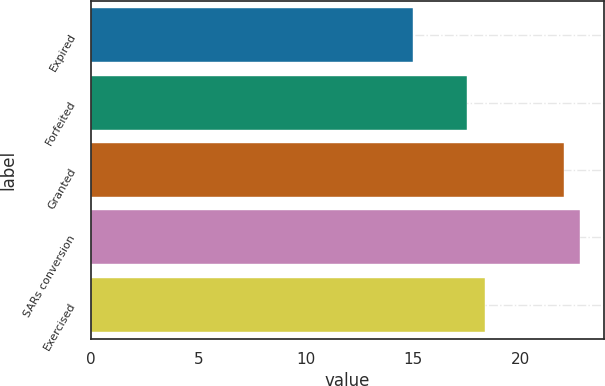<chart> <loc_0><loc_0><loc_500><loc_500><bar_chart><fcel>Expired<fcel>Forfeited<fcel>Granted<fcel>SARs conversion<fcel>Exercised<nl><fcel>14.97<fcel>17.49<fcel>22<fcel>22.74<fcel>18.33<nl></chart> 